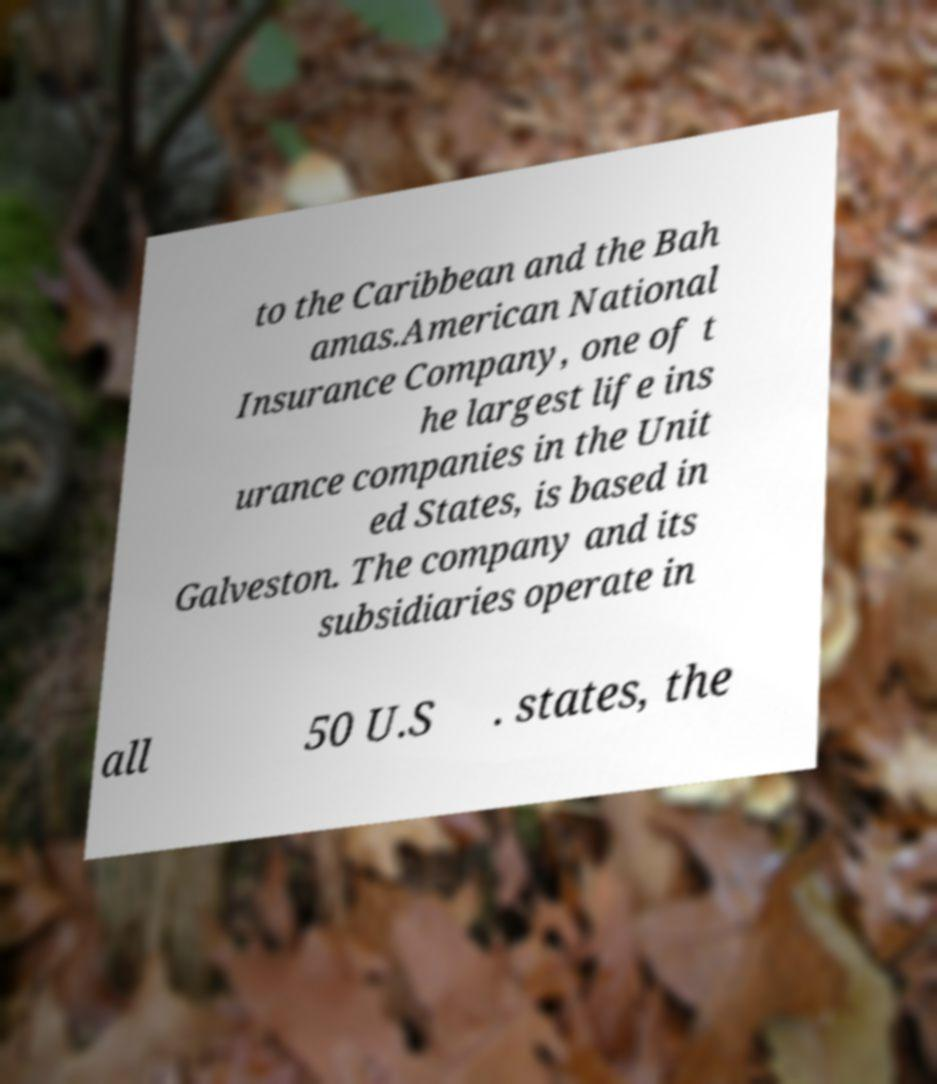Please identify and transcribe the text found in this image. to the Caribbean and the Bah amas.American National Insurance Company, one of t he largest life ins urance companies in the Unit ed States, is based in Galveston. The company and its subsidiaries operate in all 50 U.S . states, the 